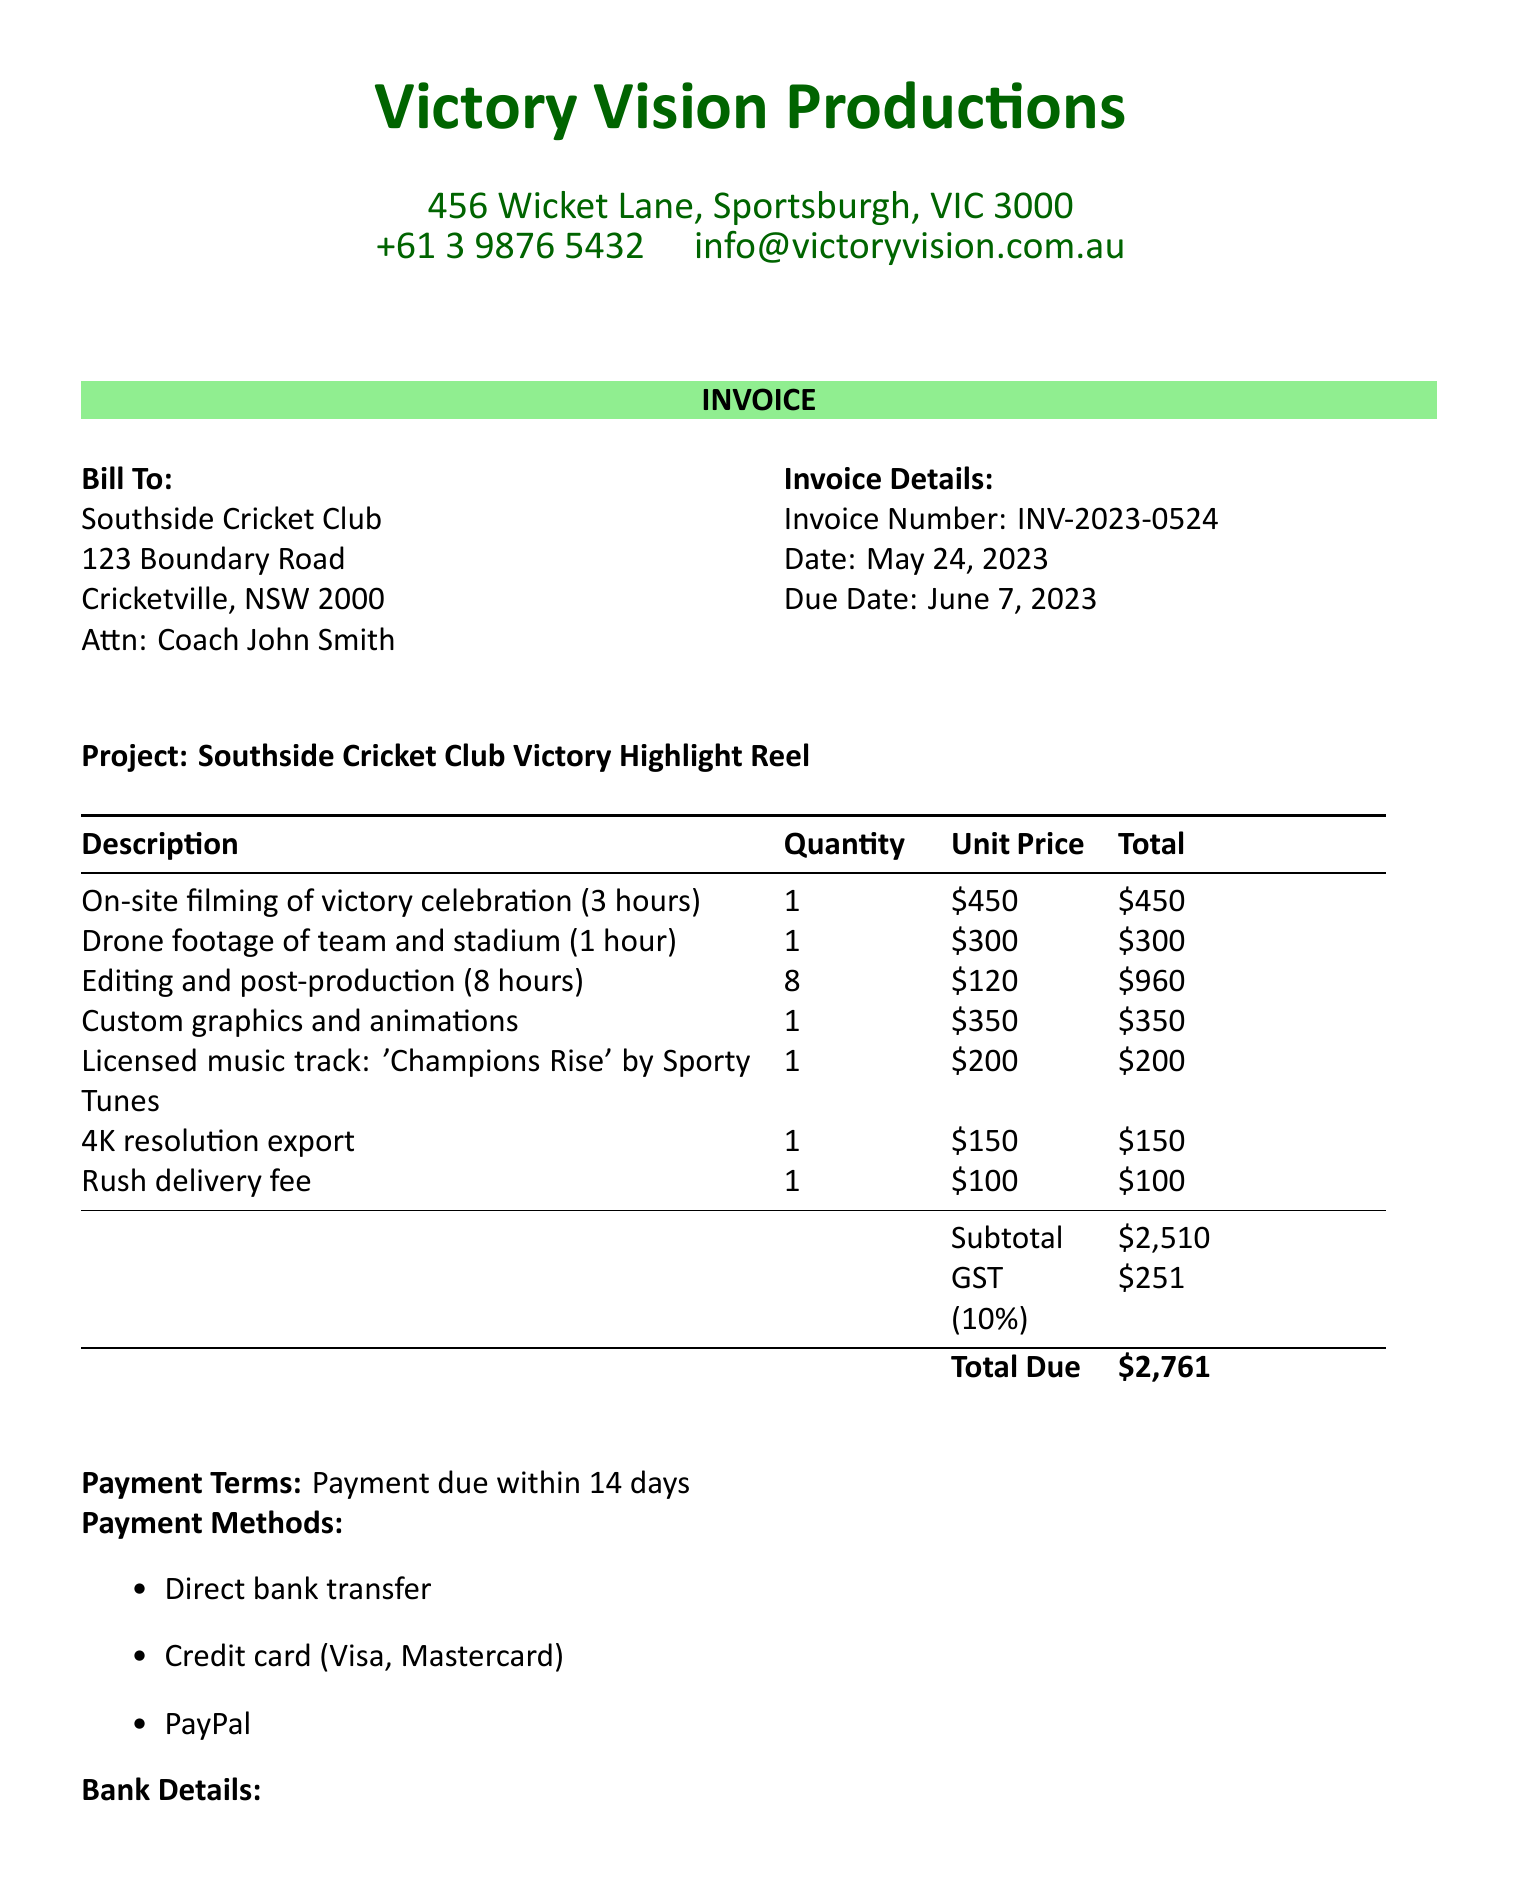What is the invoice number? The invoice number is specified in the document as a unique identifier for this transaction.
Answer: INV-2023-0524 What is the date of the invoice? The date is mentioned as part of the invoice details, indicating when the invoice was issued.
Answer: May 24, 2023 Who is the client contact person? The contact person for the client is listed in the client information section of the invoice.
Answer: Coach John Smith What is the total amount due? The total amount due is calculated at the end of the invoice, representing the full charge after tax.
Answer: $2761 How many hours of editing and post-production are included? This information is found in the line items, specifying the hours allocated for editing services.
Answer: 8 hours What type of payment methods are accepted? The document outlines various ways clients can make payments for services rendered.
Answer: Direct bank transfer, Credit card (Visa, Mastercard), PayPal What is included in the highlight reel? The notes section provides a summary of the content that the highlight reel will cover.
Answer: Footage of team celebration, individual player interviews, and key moments from the winning match When is the payment due? The payment terms specify the timeframe within which the payment needs to be completed to avoid any delays.
Answer: June 7, 2023 What is the service provider's email address? This contact detail is included under the service provider's information section of the invoice.
Answer: info@victoryvision.com.au 